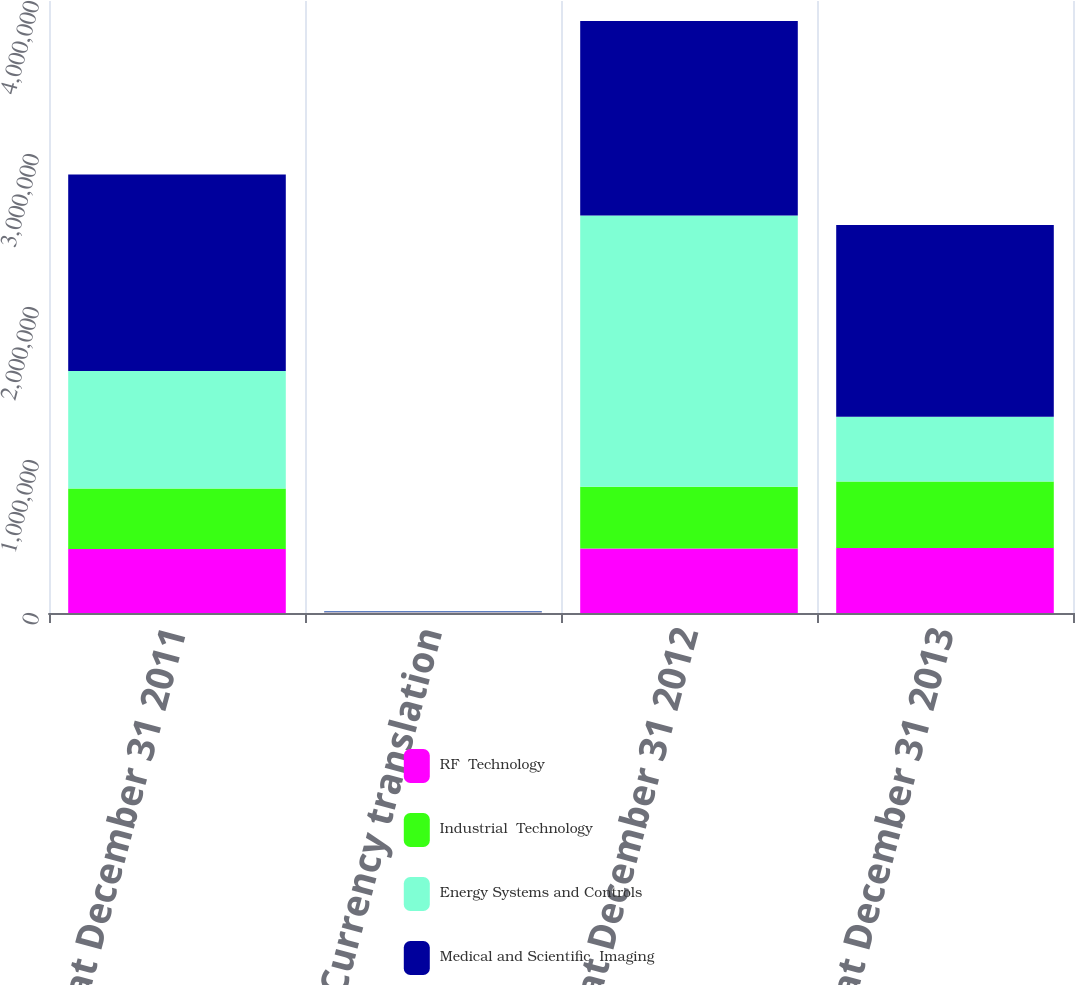Convert chart. <chart><loc_0><loc_0><loc_500><loc_500><stacked_bar_chart><ecel><fcel>Balances at December 31 2011<fcel>Currency translation<fcel>Balances at December 31 2012<fcel>Balances at December 31 2013<nl><fcel>RF  Technology<fcel>419053<fcel>2702<fcel>421755<fcel>425501<nl><fcel>Industrial  Technology<fcel>393967<fcel>1420<fcel>404057<fcel>434697<nl><fcel>Energy Systems and Controls<fcel>768228<fcel>5144<fcel>1.7724e+06<fcel>421755<nl><fcel>Medical and Scientific  Imaging<fcel>1.28518e+06<fcel>3395<fcel>1.27064e+06<fcel>1.25429e+06<nl></chart> 